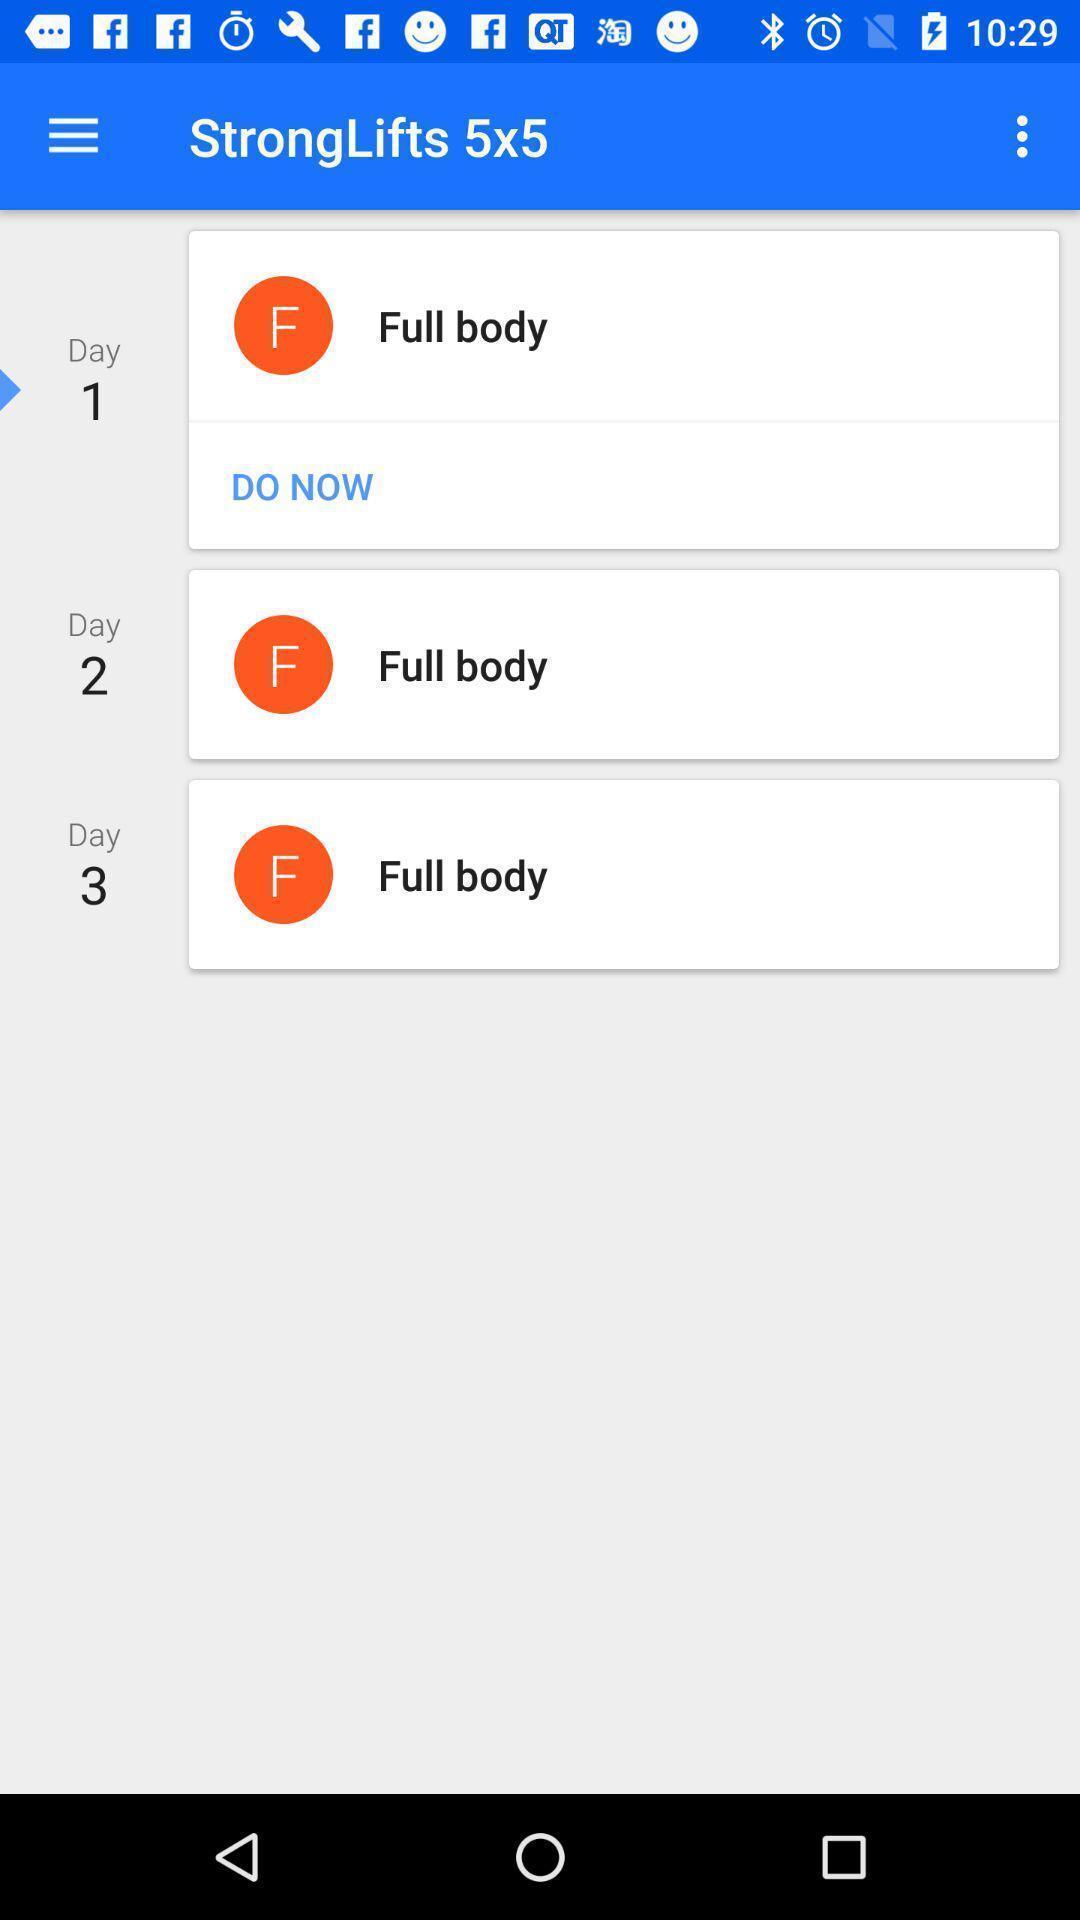Give me a summary of this screen capture. Page that displaying fitness application. 